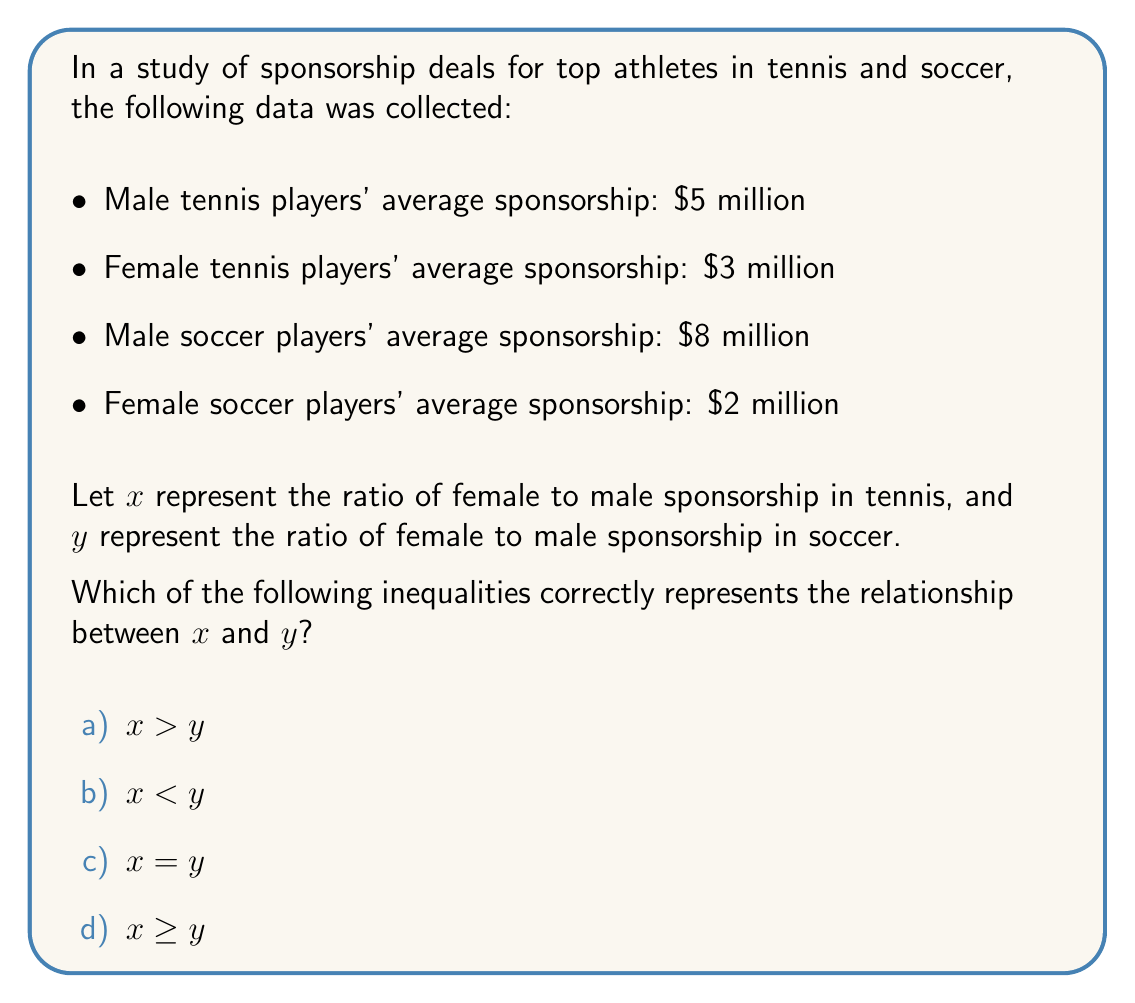Give your solution to this math problem. To solve this problem, we need to calculate the ratios of female to male sponsorship for both tennis and soccer, then compare them.

1. For tennis:
   $x = \frac{\text{Female tennis sponsorship}}{\text{Male tennis sponsorship}} = \frac{3}{5} = 0.6$

2. For soccer:
   $y = \frac{\text{Female soccer sponsorship}}{\text{Male soccer sponsorship}} = \frac{2}{8} = 0.25$

3. Compare $x$ and $y$:
   $0.6 > 0.25$

Therefore, $x > y$, which means the ratio of female to male sponsorship is greater in tennis than in soccer.

This inequality highlights that while there is still a gap in sponsorship between male and female athletes in both sports, the disparity is less pronounced in tennis compared to soccer. This analysis is relevant to the given persona, as it provides quantitative evidence for discussions about gender representation and equality in sports sponsorships.
Answer: a) $x > y$ 